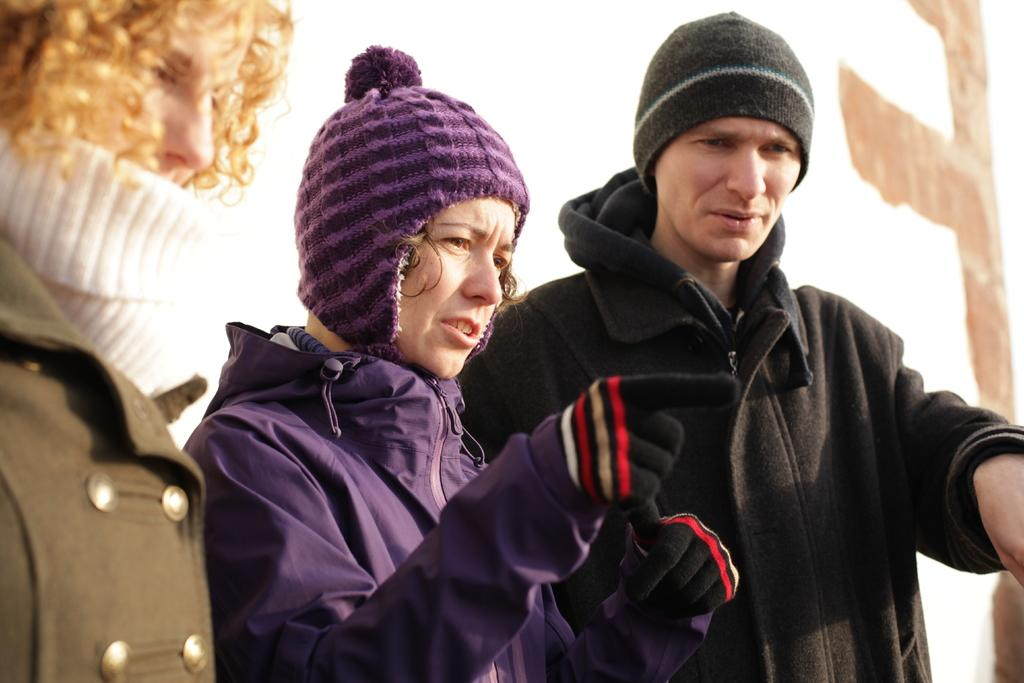How many people are in the image? There are three persons in the image. What type of clothing are the persons wearing on their upper bodies? The persons are wearing sweaters. What type of headwear are the persons wearing? The persons are wearing caps. What type of potato is being divided in the image? There is no potato present in the image. Is there an attack happening in the image? There is no indication of an attack in the image. 